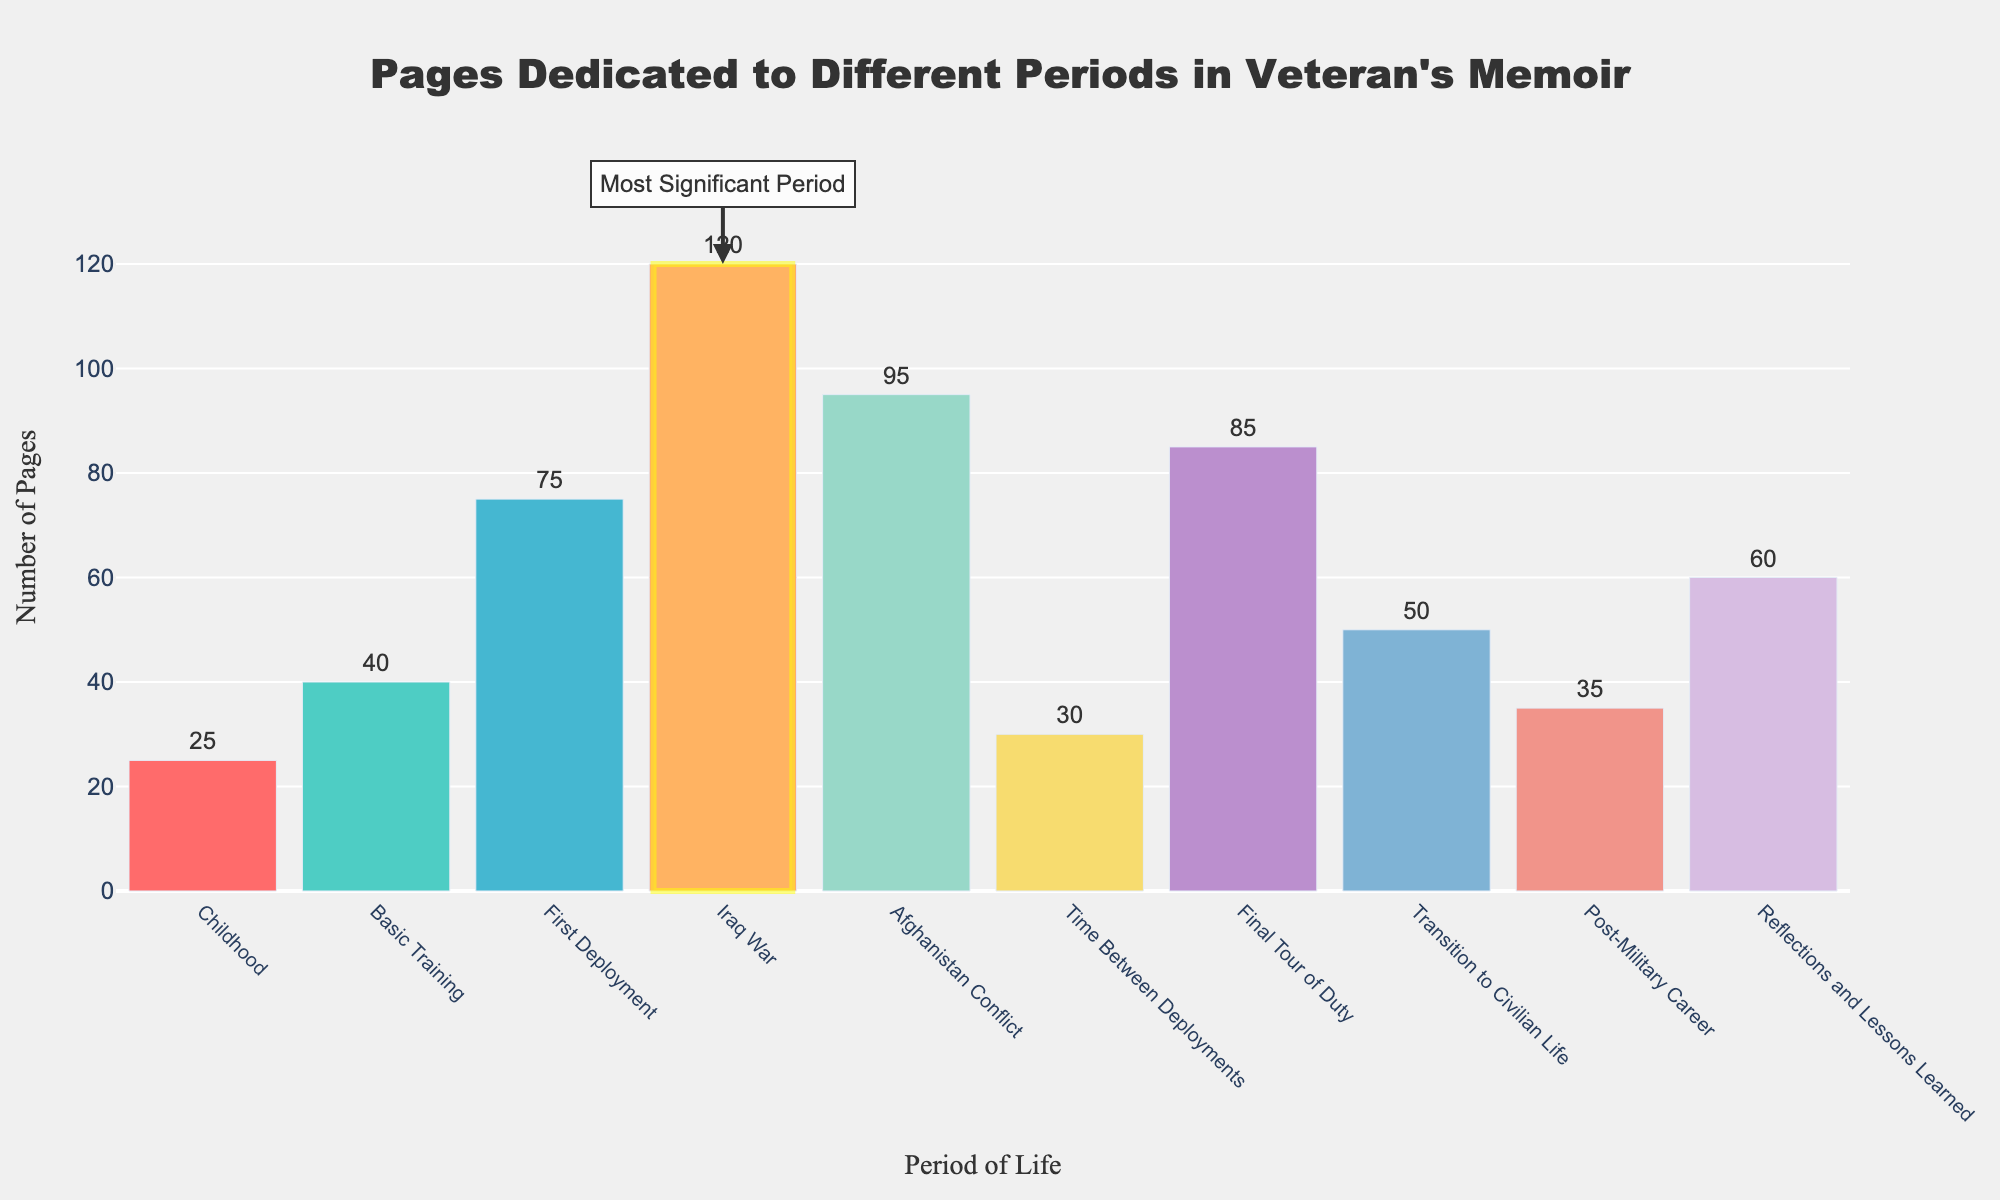what is the period with the highest number of pages? By looking at the bar heights, the Iraq War period has the highest number of pages at 120 which is also visually highlighted by the added rectangle shape.
Answer: Iraq War How many pages in total are dedicated to the two deployment periods (First Deployment and Final Tour of Duty)? Adding the pages dedicated to First Deployment (75) and Final Tour of Duty (85) gives the total pages. 75 + 85 = 160
Answer: 160 Which period has more pages dedicated to it: Basic Training or Transition to Civilian Life? The pages dedicated to Basic Training are 40 and the pages dedicated to Transition to Civilian Life are 50. Comparing these, Transition to Civilian Life has more pages.
Answer: Transition to Civilian Life What is the difference in the number of pages dedicated to the Afghanistan Conflict compared to Basic Training? The pages dedicated to Afghanistan Conflict are 95 while Basic Training has 40 pages. The difference is 95 - 40 = 55
Answer: 55 Which period has fewer pages: Post-Military Career or Reflections and Lessons Learned? Post-Military Career has 35 pages, and Reflections and Lessons Learned has 60 pages. Post-Military Career has fewer pages.
Answer: Post-Military Career Which period has the closest number of pages to the average number of pages across all periods? The average number of pages is calculated as the total number of pages divided by the number of periods. (25+40+75+120+95+30+85+50+35+60)/10 = 61.5. Reflections and Lessons Learned has 60 pages which is closest to the average.
Answer: Reflections and Lessons Learned How many pages were dedicated to the combat/conflict periods (Iraq War and Afghanistan Conflict)? Summing the pages dedicated to the Iraq War (120) and Afghanistan Conflict (95) gives 120 + 95 = 215
Answer: 215 What is the combined number of pages dedicated to periods before the first deployment (Childhood and Basic Training)? Adding 25 pages from Childhood and 40 pages from Basic Training gives the total as 25 + 40 = 65
Answer: 65 